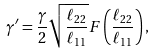<formula> <loc_0><loc_0><loc_500><loc_500>\gamma ^ { \prime } = \frac { \gamma } { 2 } \sqrt { \frac { \ell _ { 2 2 } } { \ell _ { 1 1 } } } F \left ( \frac { \ell _ { 2 2 } } { \ell _ { 1 1 } } \right ) ,</formula> 